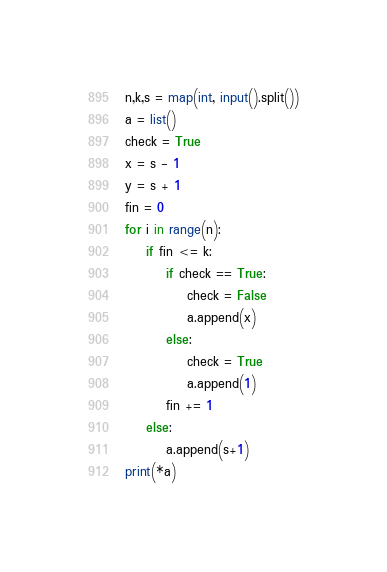Convert code to text. <code><loc_0><loc_0><loc_500><loc_500><_Python_>n,k,s = map(int, input().split())
a = list()
check = True
x = s - 1
y = s + 1
fin = 0
for i in range(n):
    if fin <= k:
        if check == True:
            check = False
            a.append(x)
        else:
            check = True
            a.append(1)
        fin += 1
    else:
        a.append(s+1)
print(*a)</code> 